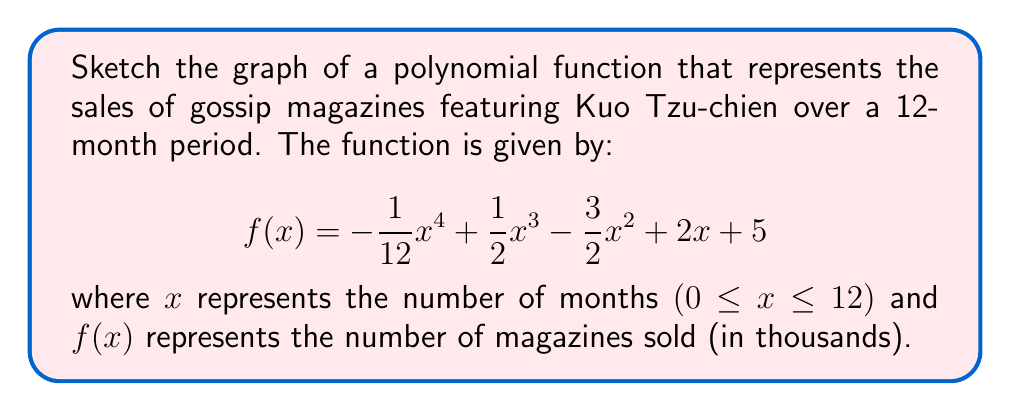What is the answer to this math problem? To sketch the graph, we'll follow these steps:

1. Find the y-intercept:
   At $x = 0$, $f(0) = 5$. So the y-intercept is (0, 5).

2. Find the roots (x-intercepts):
   This is a 4th degree polynomial, so finding exact roots is complex. We can see there are no real roots in the given domain (0 ≤ x ≤ 12).

3. Find the critical points by setting $f'(x) = 0$:
   $$f'(x) = -\frac{1}{3}x^3 + \frac{3}{2}x^2 - 3x + 2$$
   Solving this cubic equation gives us critical points at approximately x ≈ 1.2, 3.8, and 7.0.

4. Determine the nature of critical points:
   By checking $f''(x)$ at these points, we find:
   x ≈ 1.2: local maximum
   x ≈ 3.8: local minimum
   x ≈ 7.0: local maximum

5. Check end behavior:
   As x → -∞, $f(x)$ → -∞
   As x → +∞, $f(x)$ → -∞

6. Sketch the graph:
   [asy]
   import graph;
   size(200,200);
   real f(real x) {return -1/12*x^4 + 1/2*x^3 - 3/2*x^2 + 2*x + 5;}
   xaxis("x",0,12,Arrow);
   yaxis("y",0,10,Arrow);
   draw(graph(f,0,12),blue);
   label("Months",12,0,E);
   label("Sales (thousands)",0,10,N);
   [/asy]

The graph shows initial growth in sales as Kuo Tzu-chien's popularity rises, followed by fluctuations that could represent changing public interest or competing news stories.
Answer: A polynomial graph with y-intercept (0,5), no x-intercepts, local maxima at x ≈ 1.2 and 7.0, and a local minimum at x ≈ 3.8. 